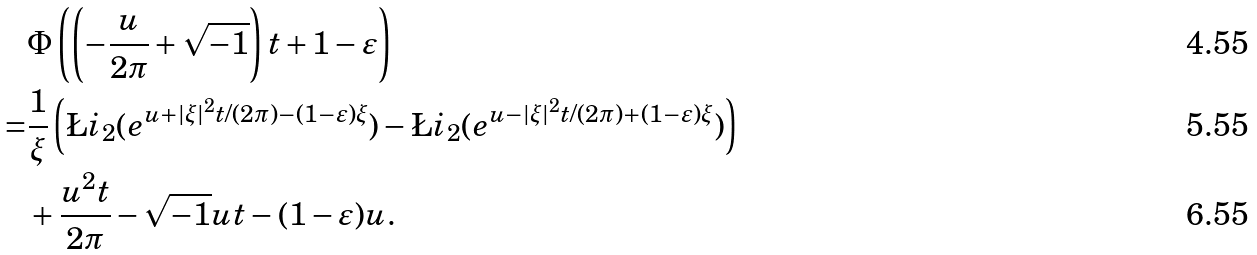Convert formula to latex. <formula><loc_0><loc_0><loc_500><loc_500>& \Phi \left ( \left ( - \frac { u } { 2 \pi } + \sqrt { - 1 } \right ) t + 1 - \varepsilon \right ) \\ = & \frac { 1 } { \xi } \left ( \L i _ { 2 } ( e ^ { u + | \xi | ^ { 2 } t / ( 2 \pi ) - ( 1 - \varepsilon ) \xi } ) - \L i _ { 2 } ( e ^ { u - | \xi | ^ { 2 } t / ( 2 \pi ) + ( 1 - \varepsilon ) \xi } ) \right ) \\ & + \frac { u ^ { 2 } t } { 2 \pi } - \sqrt { - 1 } u t - ( 1 - \varepsilon ) u .</formula> 